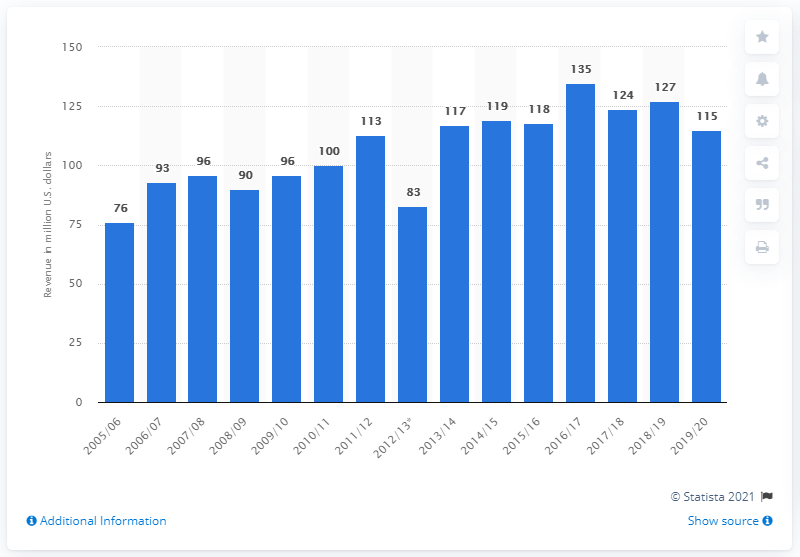Point out several critical features in this image. In the 2019/2020 season, the Ottawa Senators earned a total of $115 million in revenue. 